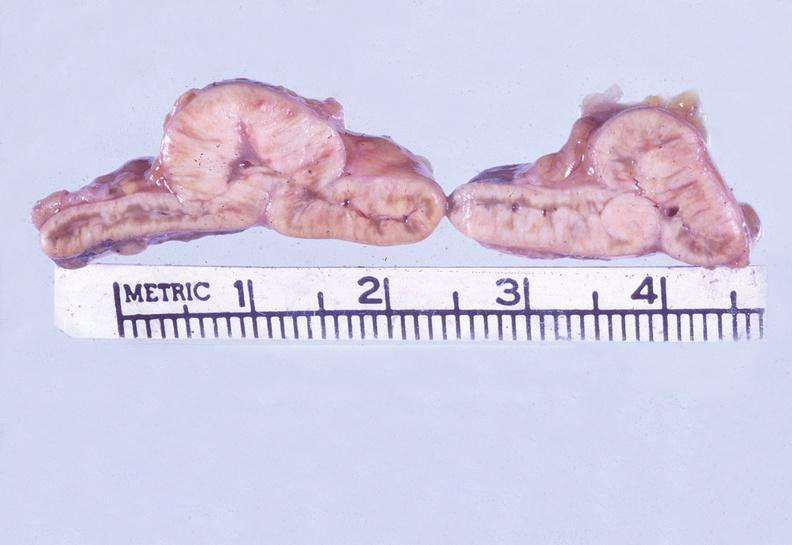s endocrine present?
Answer the question using a single word or phrase. Yes 